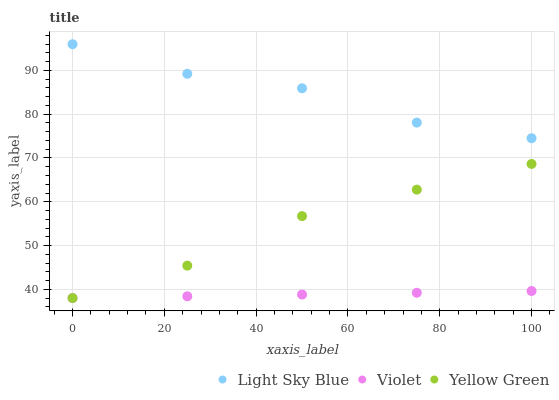Does Violet have the minimum area under the curve?
Answer yes or no. Yes. Does Light Sky Blue have the maximum area under the curve?
Answer yes or no. Yes. Does Yellow Green have the minimum area under the curve?
Answer yes or no. No. Does Yellow Green have the maximum area under the curve?
Answer yes or no. No. Is Violet the smoothest?
Answer yes or no. Yes. Is Light Sky Blue the roughest?
Answer yes or no. Yes. Is Yellow Green the smoothest?
Answer yes or no. No. Is Yellow Green the roughest?
Answer yes or no. No. Does Yellow Green have the lowest value?
Answer yes or no. Yes. Does Light Sky Blue have the highest value?
Answer yes or no. Yes. Does Yellow Green have the highest value?
Answer yes or no. No. Is Violet less than Light Sky Blue?
Answer yes or no. Yes. Is Light Sky Blue greater than Violet?
Answer yes or no. Yes. Does Yellow Green intersect Violet?
Answer yes or no. Yes. Is Yellow Green less than Violet?
Answer yes or no. No. Is Yellow Green greater than Violet?
Answer yes or no. No. Does Violet intersect Light Sky Blue?
Answer yes or no. No. 